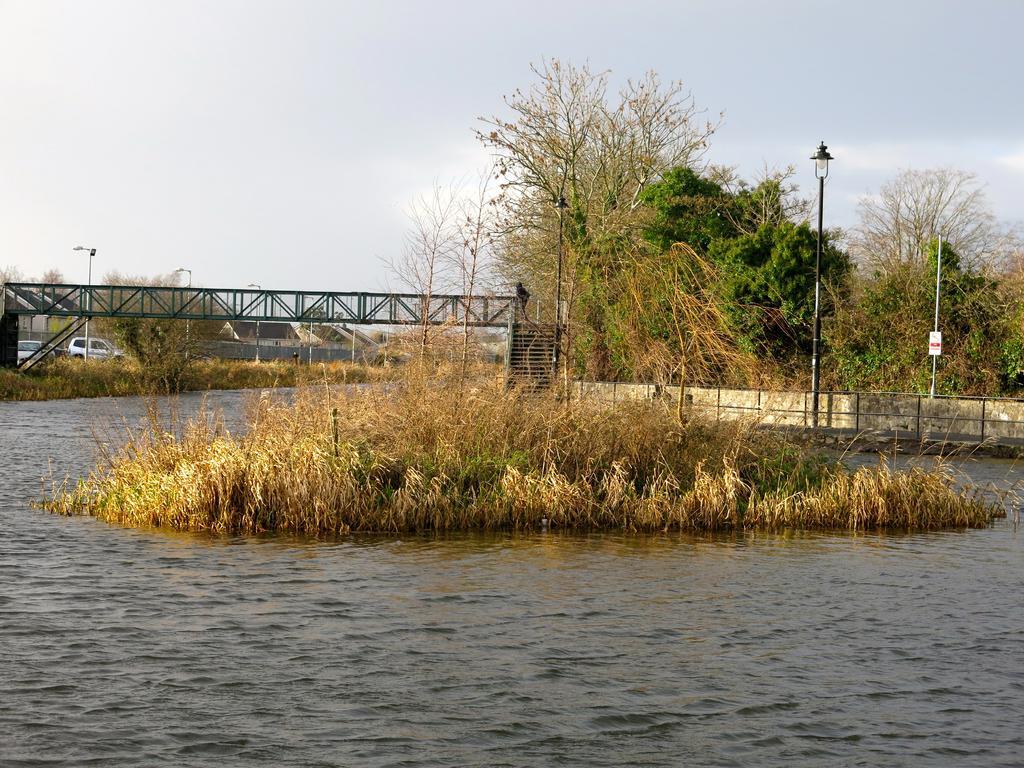How would you summarize this image in a sentence or two? This image is clicked outside. In this image there is a bridge, green plants and trees along with dry grass. There is water in the river. In the background, there are cars along with sky. 